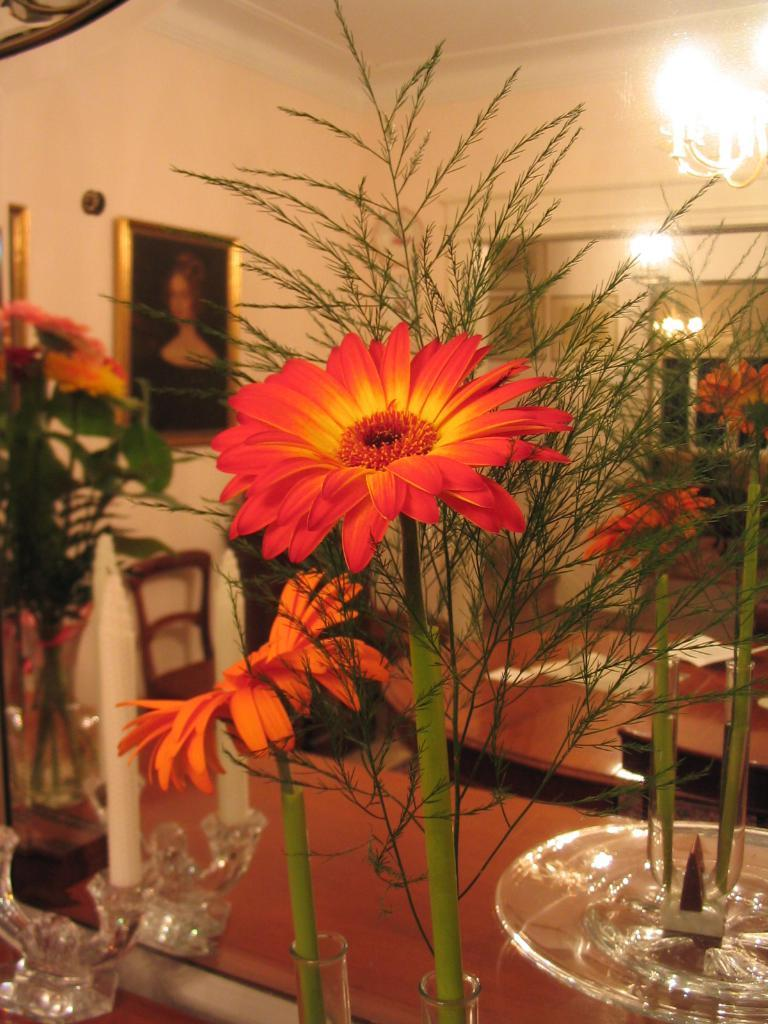What type of flora is present in the image? The image features flowers. What can be seen on the wall in the image? There is a picture on a wall in the image. What is the source of light in the image? There is a light on top in the image. What is placed on the table in the image? There is a candle and a flower vase on the table in the image. What type of furniture is visible in the image? There is a chair visible in the image. What type of prose is being recited by the yak in the image? There is no yak present in the image, and therefore no prose being recited. How many students are attending the class in the image? There is no class present in the image, so it is not possible to determine the number of students attending. 